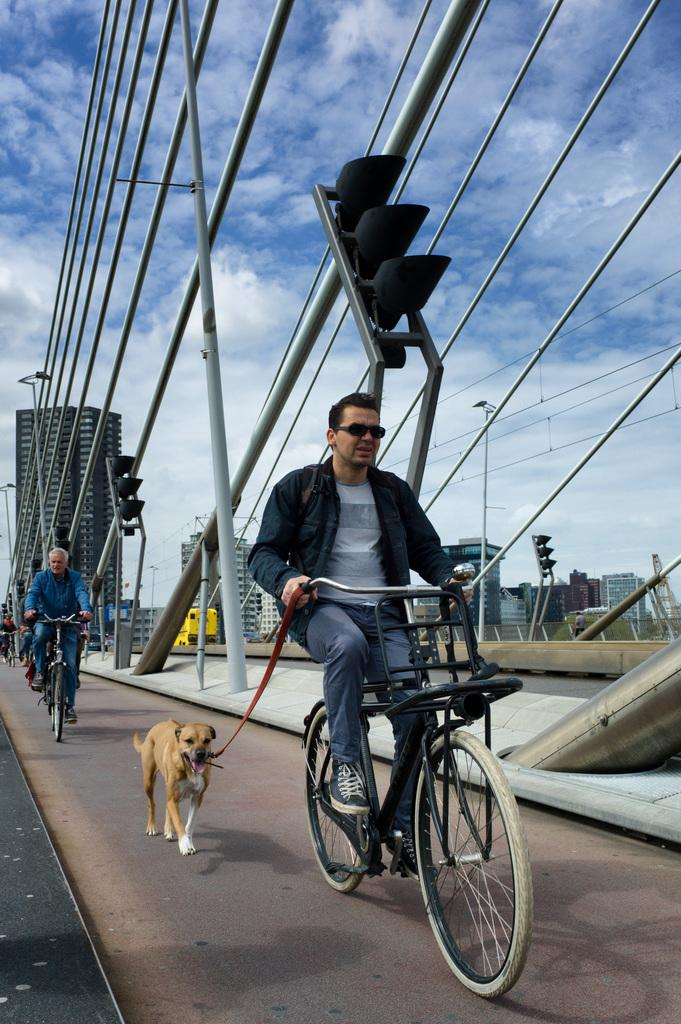What is the main subject of the image? There is a person riding a bicycle in the image. What is the person holding while riding the bicycle? The person is holding a dog's leash. Are there any other people in the image? Yes, there are other people riding bicycles in the image. What can be seen in the background of the image? There are buildings visible in the background of the image. What type of attraction can be seen in the image? There is no attraction present in the image; it features a person riding a bicycle with a dog's leash and other people riding bicycles. What sound does the horn make in the image? There is no horn present in the image. 